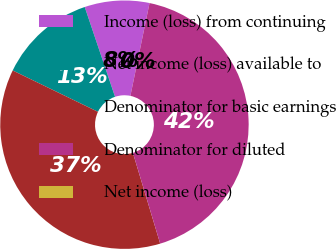Convert chart to OTSL. <chart><loc_0><loc_0><loc_500><loc_500><pie_chart><fcel>Income (loss) from continuing<fcel>Net income (loss) available to<fcel>Denominator for basic earnings<fcel>Denominator for diluted<fcel>Net income (loss)<nl><fcel>8.42%<fcel>12.63%<fcel>36.83%<fcel>42.11%<fcel>0.0%<nl></chart> 